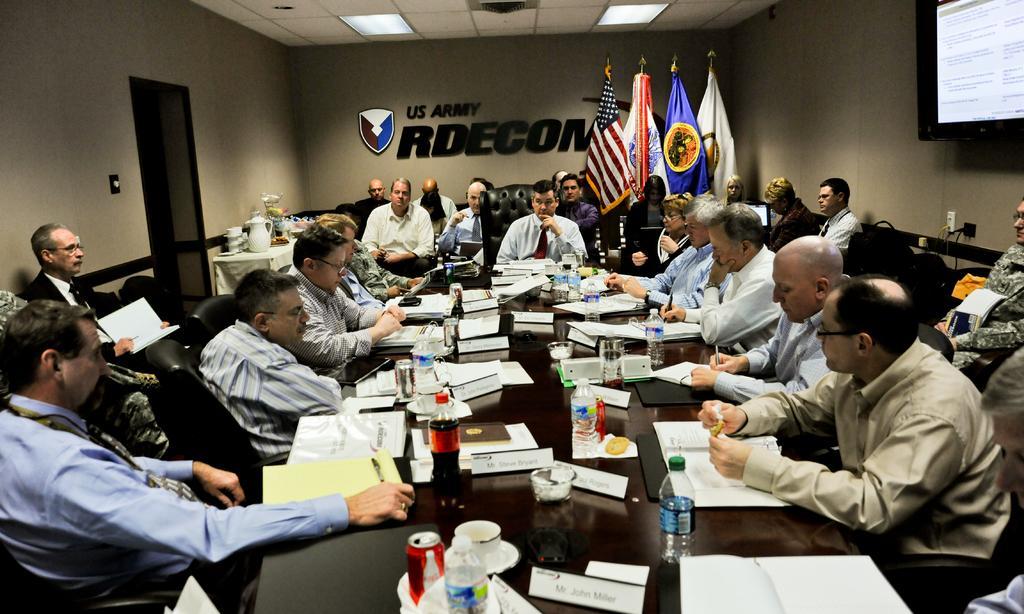How would you summarize this image in a sentence or two? In the picture there is a room, in the room there are people sitting on the chairs with the table in front of them, on the table there are many items such as books, glasses, bottles with the liquid, bowls, name plates, there are poles with the flags, there is some text on the wall, there is a small table near the wall, on the table there is a jug, cups and some items, there are lights on the roof, there is a screen on the wall, there may be cable sockets on the wall. 